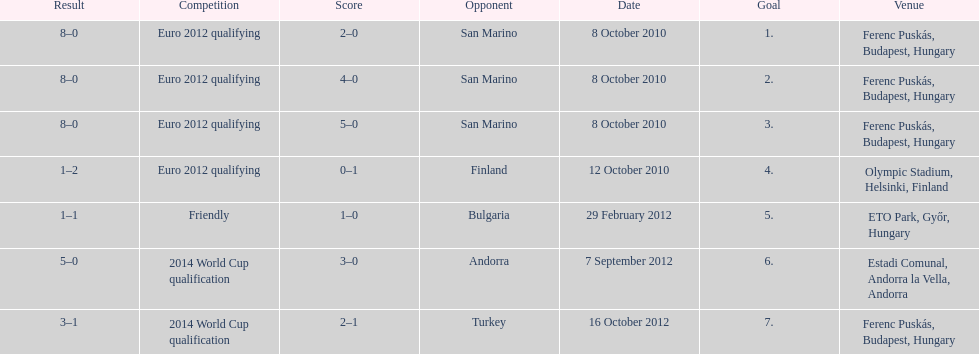In what year did ádám szalai make his next international goal after 2010? 2012. 